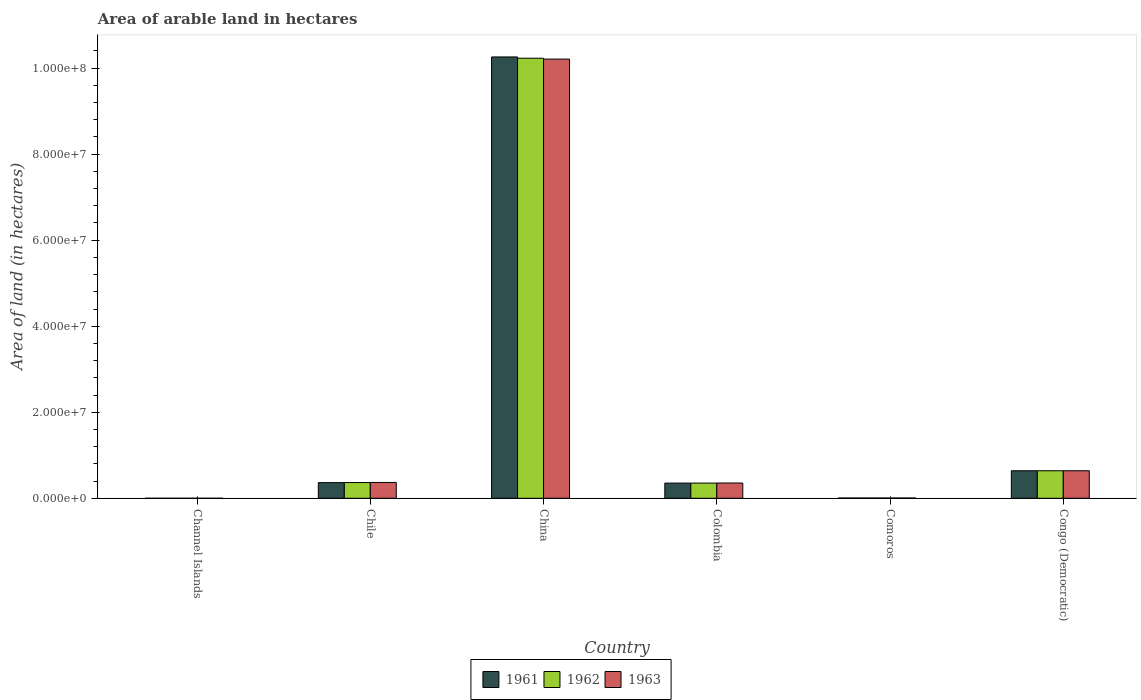How many bars are there on the 3rd tick from the left?
Offer a terse response. 3. What is the label of the 5th group of bars from the left?
Provide a succinct answer. Comoros. What is the total arable land in 1963 in Colombia?
Your answer should be very brief. 3.55e+06. Across all countries, what is the maximum total arable land in 1963?
Ensure brevity in your answer.  1.02e+08. Across all countries, what is the minimum total arable land in 1962?
Make the answer very short. 4000. In which country was the total arable land in 1962 minimum?
Provide a short and direct response. Channel Islands. What is the total total arable land in 1963 in the graph?
Offer a terse response. 1.16e+08. What is the difference between the total arable land in 1963 in Chile and that in China?
Give a very brief answer. -9.84e+07. What is the difference between the total arable land in 1961 in Colombia and the total arable land in 1962 in Channel Islands?
Ensure brevity in your answer.  3.53e+06. What is the average total arable land in 1963 per country?
Offer a terse response. 1.93e+07. What is the difference between the total arable land of/in 1962 and total arable land of/in 1963 in China?
Keep it short and to the point. 2.00e+05. In how many countries, is the total arable land in 1961 greater than 44000000 hectares?
Give a very brief answer. 1. What is the ratio of the total arable land in 1963 in China to that in Congo (Democratic)?
Provide a short and direct response. 15.95. Is the difference between the total arable land in 1962 in Chile and Colombia greater than the difference between the total arable land in 1963 in Chile and Colombia?
Offer a terse response. No. What is the difference between the highest and the second highest total arable land in 1962?
Make the answer very short. 9.59e+07. What is the difference between the highest and the lowest total arable land in 1962?
Offer a very short reply. 1.02e+08. In how many countries, is the total arable land in 1961 greater than the average total arable land in 1961 taken over all countries?
Give a very brief answer. 1. What does the 2nd bar from the left in Comoros represents?
Ensure brevity in your answer.  1962. What does the 1st bar from the right in Channel Islands represents?
Give a very brief answer. 1963. Is it the case that in every country, the sum of the total arable land in 1961 and total arable land in 1962 is greater than the total arable land in 1963?
Ensure brevity in your answer.  Yes. Are the values on the major ticks of Y-axis written in scientific E-notation?
Offer a very short reply. Yes. Does the graph contain grids?
Provide a succinct answer. No. What is the title of the graph?
Offer a very short reply. Area of arable land in hectares. What is the label or title of the Y-axis?
Give a very brief answer. Area of land (in hectares). What is the Area of land (in hectares) in 1961 in Channel Islands?
Make the answer very short. 4000. What is the Area of land (in hectares) in 1962 in Channel Islands?
Give a very brief answer. 4000. What is the Area of land (in hectares) in 1963 in Channel Islands?
Provide a succinct answer. 4000. What is the Area of land (in hectares) in 1961 in Chile?
Your answer should be compact. 3.64e+06. What is the Area of land (in hectares) in 1962 in Chile?
Provide a succinct answer. 3.66e+06. What is the Area of land (in hectares) of 1963 in Chile?
Your answer should be very brief. 3.68e+06. What is the Area of land (in hectares) of 1961 in China?
Ensure brevity in your answer.  1.03e+08. What is the Area of land (in hectares) of 1962 in China?
Make the answer very short. 1.02e+08. What is the Area of land (in hectares) of 1963 in China?
Provide a succinct answer. 1.02e+08. What is the Area of land (in hectares) in 1961 in Colombia?
Your answer should be very brief. 3.53e+06. What is the Area of land (in hectares) in 1962 in Colombia?
Give a very brief answer. 3.53e+06. What is the Area of land (in hectares) in 1963 in Colombia?
Your answer should be very brief. 3.55e+06. What is the Area of land (in hectares) in 1961 in Comoros?
Ensure brevity in your answer.  6.50e+04. What is the Area of land (in hectares) of 1962 in Comoros?
Keep it short and to the point. 6.50e+04. What is the Area of land (in hectares) of 1963 in Comoros?
Provide a succinct answer. 6.50e+04. What is the Area of land (in hectares) of 1961 in Congo (Democratic)?
Offer a terse response. 6.40e+06. What is the Area of land (in hectares) of 1962 in Congo (Democratic)?
Ensure brevity in your answer.  6.40e+06. What is the Area of land (in hectares) of 1963 in Congo (Democratic)?
Offer a very short reply. 6.40e+06. Across all countries, what is the maximum Area of land (in hectares) in 1961?
Provide a short and direct response. 1.03e+08. Across all countries, what is the maximum Area of land (in hectares) in 1962?
Your response must be concise. 1.02e+08. Across all countries, what is the maximum Area of land (in hectares) of 1963?
Your response must be concise. 1.02e+08. Across all countries, what is the minimum Area of land (in hectares) in 1961?
Ensure brevity in your answer.  4000. Across all countries, what is the minimum Area of land (in hectares) in 1962?
Ensure brevity in your answer.  4000. Across all countries, what is the minimum Area of land (in hectares) in 1963?
Provide a succinct answer. 4000. What is the total Area of land (in hectares) in 1961 in the graph?
Your response must be concise. 1.16e+08. What is the total Area of land (in hectares) of 1962 in the graph?
Give a very brief answer. 1.16e+08. What is the total Area of land (in hectares) in 1963 in the graph?
Offer a terse response. 1.16e+08. What is the difference between the Area of land (in hectares) in 1961 in Channel Islands and that in Chile?
Give a very brief answer. -3.64e+06. What is the difference between the Area of land (in hectares) of 1962 in Channel Islands and that in Chile?
Offer a very short reply. -3.66e+06. What is the difference between the Area of land (in hectares) of 1963 in Channel Islands and that in Chile?
Provide a succinct answer. -3.68e+06. What is the difference between the Area of land (in hectares) of 1961 in Channel Islands and that in China?
Keep it short and to the point. -1.03e+08. What is the difference between the Area of land (in hectares) in 1962 in Channel Islands and that in China?
Your answer should be very brief. -1.02e+08. What is the difference between the Area of land (in hectares) of 1963 in Channel Islands and that in China?
Provide a short and direct response. -1.02e+08. What is the difference between the Area of land (in hectares) of 1961 in Channel Islands and that in Colombia?
Give a very brief answer. -3.53e+06. What is the difference between the Area of land (in hectares) in 1962 in Channel Islands and that in Colombia?
Offer a very short reply. -3.53e+06. What is the difference between the Area of land (in hectares) in 1963 in Channel Islands and that in Colombia?
Your response must be concise. -3.55e+06. What is the difference between the Area of land (in hectares) of 1961 in Channel Islands and that in Comoros?
Provide a succinct answer. -6.10e+04. What is the difference between the Area of land (in hectares) of 1962 in Channel Islands and that in Comoros?
Your answer should be compact. -6.10e+04. What is the difference between the Area of land (in hectares) in 1963 in Channel Islands and that in Comoros?
Keep it short and to the point. -6.10e+04. What is the difference between the Area of land (in hectares) of 1961 in Channel Islands and that in Congo (Democratic)?
Your response must be concise. -6.40e+06. What is the difference between the Area of land (in hectares) of 1962 in Channel Islands and that in Congo (Democratic)?
Keep it short and to the point. -6.40e+06. What is the difference between the Area of land (in hectares) of 1963 in Channel Islands and that in Congo (Democratic)?
Your answer should be very brief. -6.40e+06. What is the difference between the Area of land (in hectares) in 1961 in Chile and that in China?
Your response must be concise. -9.90e+07. What is the difference between the Area of land (in hectares) of 1962 in Chile and that in China?
Your answer should be compact. -9.86e+07. What is the difference between the Area of land (in hectares) in 1963 in Chile and that in China?
Provide a succinct answer. -9.84e+07. What is the difference between the Area of land (in hectares) in 1961 in Chile and that in Colombia?
Your answer should be very brief. 1.08e+05. What is the difference between the Area of land (in hectares) in 1962 in Chile and that in Colombia?
Offer a terse response. 1.28e+05. What is the difference between the Area of land (in hectares) of 1963 in Chile and that in Colombia?
Your answer should be compact. 1.30e+05. What is the difference between the Area of land (in hectares) in 1961 in Chile and that in Comoros?
Your answer should be compact. 3.58e+06. What is the difference between the Area of land (in hectares) in 1962 in Chile and that in Comoros?
Offer a very short reply. 3.60e+06. What is the difference between the Area of land (in hectares) in 1963 in Chile and that in Comoros?
Offer a terse response. 3.62e+06. What is the difference between the Area of land (in hectares) in 1961 in Chile and that in Congo (Democratic)?
Give a very brief answer. -2.76e+06. What is the difference between the Area of land (in hectares) in 1962 in Chile and that in Congo (Democratic)?
Offer a terse response. -2.74e+06. What is the difference between the Area of land (in hectares) in 1963 in Chile and that in Congo (Democratic)?
Offer a terse response. -2.72e+06. What is the difference between the Area of land (in hectares) in 1961 in China and that in Colombia?
Offer a terse response. 9.91e+07. What is the difference between the Area of land (in hectares) in 1962 in China and that in Colombia?
Offer a very short reply. 9.88e+07. What is the difference between the Area of land (in hectares) of 1963 in China and that in Colombia?
Ensure brevity in your answer.  9.86e+07. What is the difference between the Area of land (in hectares) in 1961 in China and that in Comoros?
Your answer should be compact. 1.03e+08. What is the difference between the Area of land (in hectares) in 1962 in China and that in Comoros?
Make the answer very short. 1.02e+08. What is the difference between the Area of land (in hectares) in 1963 in China and that in Comoros?
Offer a terse response. 1.02e+08. What is the difference between the Area of land (in hectares) in 1961 in China and that in Congo (Democratic)?
Your answer should be very brief. 9.62e+07. What is the difference between the Area of land (in hectares) in 1962 in China and that in Congo (Democratic)?
Ensure brevity in your answer.  9.59e+07. What is the difference between the Area of land (in hectares) of 1963 in China and that in Congo (Democratic)?
Provide a succinct answer. 9.57e+07. What is the difference between the Area of land (in hectares) in 1961 in Colombia and that in Comoros?
Offer a terse response. 3.47e+06. What is the difference between the Area of land (in hectares) of 1962 in Colombia and that in Comoros?
Provide a succinct answer. 3.47e+06. What is the difference between the Area of land (in hectares) of 1963 in Colombia and that in Comoros?
Offer a terse response. 3.48e+06. What is the difference between the Area of land (in hectares) of 1961 in Colombia and that in Congo (Democratic)?
Your answer should be very brief. -2.87e+06. What is the difference between the Area of land (in hectares) of 1962 in Colombia and that in Congo (Democratic)?
Provide a short and direct response. -2.87e+06. What is the difference between the Area of land (in hectares) in 1963 in Colombia and that in Congo (Democratic)?
Provide a succinct answer. -2.85e+06. What is the difference between the Area of land (in hectares) of 1961 in Comoros and that in Congo (Democratic)?
Keep it short and to the point. -6.34e+06. What is the difference between the Area of land (in hectares) in 1962 in Comoros and that in Congo (Democratic)?
Make the answer very short. -6.34e+06. What is the difference between the Area of land (in hectares) in 1963 in Comoros and that in Congo (Democratic)?
Your answer should be compact. -6.34e+06. What is the difference between the Area of land (in hectares) in 1961 in Channel Islands and the Area of land (in hectares) in 1962 in Chile?
Provide a succinct answer. -3.66e+06. What is the difference between the Area of land (in hectares) in 1961 in Channel Islands and the Area of land (in hectares) in 1963 in Chile?
Make the answer very short. -3.68e+06. What is the difference between the Area of land (in hectares) of 1962 in Channel Islands and the Area of land (in hectares) of 1963 in Chile?
Provide a short and direct response. -3.68e+06. What is the difference between the Area of land (in hectares) in 1961 in Channel Islands and the Area of land (in hectares) in 1962 in China?
Give a very brief answer. -1.02e+08. What is the difference between the Area of land (in hectares) of 1961 in Channel Islands and the Area of land (in hectares) of 1963 in China?
Provide a short and direct response. -1.02e+08. What is the difference between the Area of land (in hectares) of 1962 in Channel Islands and the Area of land (in hectares) of 1963 in China?
Your response must be concise. -1.02e+08. What is the difference between the Area of land (in hectares) in 1961 in Channel Islands and the Area of land (in hectares) in 1962 in Colombia?
Ensure brevity in your answer.  -3.53e+06. What is the difference between the Area of land (in hectares) in 1961 in Channel Islands and the Area of land (in hectares) in 1963 in Colombia?
Give a very brief answer. -3.55e+06. What is the difference between the Area of land (in hectares) in 1962 in Channel Islands and the Area of land (in hectares) in 1963 in Colombia?
Give a very brief answer. -3.55e+06. What is the difference between the Area of land (in hectares) in 1961 in Channel Islands and the Area of land (in hectares) in 1962 in Comoros?
Offer a terse response. -6.10e+04. What is the difference between the Area of land (in hectares) of 1961 in Channel Islands and the Area of land (in hectares) of 1963 in Comoros?
Offer a very short reply. -6.10e+04. What is the difference between the Area of land (in hectares) in 1962 in Channel Islands and the Area of land (in hectares) in 1963 in Comoros?
Your answer should be very brief. -6.10e+04. What is the difference between the Area of land (in hectares) of 1961 in Channel Islands and the Area of land (in hectares) of 1962 in Congo (Democratic)?
Your answer should be very brief. -6.40e+06. What is the difference between the Area of land (in hectares) of 1961 in Channel Islands and the Area of land (in hectares) of 1963 in Congo (Democratic)?
Your answer should be very brief. -6.40e+06. What is the difference between the Area of land (in hectares) in 1962 in Channel Islands and the Area of land (in hectares) in 1963 in Congo (Democratic)?
Provide a succinct answer. -6.40e+06. What is the difference between the Area of land (in hectares) in 1961 in Chile and the Area of land (in hectares) in 1962 in China?
Your answer should be very brief. -9.87e+07. What is the difference between the Area of land (in hectares) of 1961 in Chile and the Area of land (in hectares) of 1963 in China?
Provide a succinct answer. -9.85e+07. What is the difference between the Area of land (in hectares) in 1962 in Chile and the Area of land (in hectares) in 1963 in China?
Ensure brevity in your answer.  -9.84e+07. What is the difference between the Area of land (in hectares) of 1961 in Chile and the Area of land (in hectares) of 1962 in Colombia?
Offer a terse response. 1.08e+05. What is the difference between the Area of land (in hectares) of 1961 in Chile and the Area of land (in hectares) of 1963 in Colombia?
Offer a very short reply. 9.00e+04. What is the difference between the Area of land (in hectares) of 1962 in Chile and the Area of land (in hectares) of 1963 in Colombia?
Your answer should be very brief. 1.10e+05. What is the difference between the Area of land (in hectares) in 1961 in Chile and the Area of land (in hectares) in 1962 in Comoros?
Your answer should be very brief. 3.58e+06. What is the difference between the Area of land (in hectares) in 1961 in Chile and the Area of land (in hectares) in 1963 in Comoros?
Make the answer very short. 3.58e+06. What is the difference between the Area of land (in hectares) in 1962 in Chile and the Area of land (in hectares) in 1963 in Comoros?
Offer a terse response. 3.60e+06. What is the difference between the Area of land (in hectares) in 1961 in Chile and the Area of land (in hectares) in 1962 in Congo (Democratic)?
Provide a short and direct response. -2.76e+06. What is the difference between the Area of land (in hectares) of 1961 in Chile and the Area of land (in hectares) of 1963 in Congo (Democratic)?
Offer a terse response. -2.76e+06. What is the difference between the Area of land (in hectares) of 1962 in Chile and the Area of land (in hectares) of 1963 in Congo (Democratic)?
Ensure brevity in your answer.  -2.74e+06. What is the difference between the Area of land (in hectares) in 1961 in China and the Area of land (in hectares) in 1962 in Colombia?
Provide a short and direct response. 9.91e+07. What is the difference between the Area of land (in hectares) in 1961 in China and the Area of land (in hectares) in 1963 in Colombia?
Make the answer very short. 9.90e+07. What is the difference between the Area of land (in hectares) of 1962 in China and the Area of land (in hectares) of 1963 in Colombia?
Provide a short and direct response. 9.88e+07. What is the difference between the Area of land (in hectares) in 1961 in China and the Area of land (in hectares) in 1962 in Comoros?
Keep it short and to the point. 1.03e+08. What is the difference between the Area of land (in hectares) of 1961 in China and the Area of land (in hectares) of 1963 in Comoros?
Provide a short and direct response. 1.03e+08. What is the difference between the Area of land (in hectares) in 1962 in China and the Area of land (in hectares) in 1963 in Comoros?
Provide a succinct answer. 1.02e+08. What is the difference between the Area of land (in hectares) in 1961 in China and the Area of land (in hectares) in 1962 in Congo (Democratic)?
Make the answer very short. 9.62e+07. What is the difference between the Area of land (in hectares) of 1961 in China and the Area of land (in hectares) of 1963 in Congo (Democratic)?
Your response must be concise. 9.62e+07. What is the difference between the Area of land (in hectares) in 1962 in China and the Area of land (in hectares) in 1963 in Congo (Democratic)?
Provide a short and direct response. 9.59e+07. What is the difference between the Area of land (in hectares) of 1961 in Colombia and the Area of land (in hectares) of 1962 in Comoros?
Provide a short and direct response. 3.47e+06. What is the difference between the Area of land (in hectares) in 1961 in Colombia and the Area of land (in hectares) in 1963 in Comoros?
Provide a succinct answer. 3.47e+06. What is the difference between the Area of land (in hectares) of 1962 in Colombia and the Area of land (in hectares) of 1963 in Comoros?
Give a very brief answer. 3.47e+06. What is the difference between the Area of land (in hectares) in 1961 in Colombia and the Area of land (in hectares) in 1962 in Congo (Democratic)?
Give a very brief answer. -2.87e+06. What is the difference between the Area of land (in hectares) in 1961 in Colombia and the Area of land (in hectares) in 1963 in Congo (Democratic)?
Ensure brevity in your answer.  -2.87e+06. What is the difference between the Area of land (in hectares) in 1962 in Colombia and the Area of land (in hectares) in 1963 in Congo (Democratic)?
Give a very brief answer. -2.87e+06. What is the difference between the Area of land (in hectares) in 1961 in Comoros and the Area of land (in hectares) in 1962 in Congo (Democratic)?
Your answer should be compact. -6.34e+06. What is the difference between the Area of land (in hectares) of 1961 in Comoros and the Area of land (in hectares) of 1963 in Congo (Democratic)?
Make the answer very short. -6.34e+06. What is the difference between the Area of land (in hectares) of 1962 in Comoros and the Area of land (in hectares) of 1963 in Congo (Democratic)?
Your response must be concise. -6.34e+06. What is the average Area of land (in hectares) of 1961 per country?
Give a very brief answer. 1.94e+07. What is the average Area of land (in hectares) in 1962 per country?
Your answer should be very brief. 1.93e+07. What is the average Area of land (in hectares) in 1963 per country?
Give a very brief answer. 1.93e+07. What is the difference between the Area of land (in hectares) in 1961 and Area of land (in hectares) in 1962 in Channel Islands?
Provide a short and direct response. 0. What is the difference between the Area of land (in hectares) in 1961 and Area of land (in hectares) in 1963 in Channel Islands?
Provide a succinct answer. 0. What is the difference between the Area of land (in hectares) of 1961 and Area of land (in hectares) of 1963 in Chile?
Give a very brief answer. -4.00e+04. What is the difference between the Area of land (in hectares) of 1961 and Area of land (in hectares) of 1963 in China?
Ensure brevity in your answer.  5.00e+05. What is the difference between the Area of land (in hectares) of 1961 and Area of land (in hectares) of 1962 in Colombia?
Offer a very short reply. 0. What is the difference between the Area of land (in hectares) of 1961 and Area of land (in hectares) of 1963 in Colombia?
Offer a very short reply. -1.80e+04. What is the difference between the Area of land (in hectares) in 1962 and Area of land (in hectares) in 1963 in Colombia?
Offer a very short reply. -1.80e+04. What is the difference between the Area of land (in hectares) in 1961 and Area of land (in hectares) in 1962 in Comoros?
Your answer should be very brief. 0. What is the difference between the Area of land (in hectares) in 1961 and Area of land (in hectares) in 1963 in Comoros?
Make the answer very short. 0. What is the ratio of the Area of land (in hectares) in 1961 in Channel Islands to that in Chile?
Provide a short and direct response. 0. What is the ratio of the Area of land (in hectares) in 1962 in Channel Islands to that in Chile?
Ensure brevity in your answer.  0. What is the ratio of the Area of land (in hectares) in 1963 in Channel Islands to that in Chile?
Give a very brief answer. 0. What is the ratio of the Area of land (in hectares) in 1963 in Channel Islands to that in China?
Your answer should be very brief. 0. What is the ratio of the Area of land (in hectares) of 1961 in Channel Islands to that in Colombia?
Offer a terse response. 0. What is the ratio of the Area of land (in hectares) of 1962 in Channel Islands to that in Colombia?
Offer a very short reply. 0. What is the ratio of the Area of land (in hectares) in 1963 in Channel Islands to that in Colombia?
Provide a short and direct response. 0. What is the ratio of the Area of land (in hectares) of 1961 in Channel Islands to that in Comoros?
Provide a succinct answer. 0.06. What is the ratio of the Area of land (in hectares) of 1962 in Channel Islands to that in Comoros?
Keep it short and to the point. 0.06. What is the ratio of the Area of land (in hectares) of 1963 in Channel Islands to that in Comoros?
Offer a terse response. 0.06. What is the ratio of the Area of land (in hectares) in 1961 in Channel Islands to that in Congo (Democratic)?
Keep it short and to the point. 0. What is the ratio of the Area of land (in hectares) in 1962 in Channel Islands to that in Congo (Democratic)?
Make the answer very short. 0. What is the ratio of the Area of land (in hectares) of 1963 in Channel Islands to that in Congo (Democratic)?
Keep it short and to the point. 0. What is the ratio of the Area of land (in hectares) in 1961 in Chile to that in China?
Offer a very short reply. 0.04. What is the ratio of the Area of land (in hectares) of 1962 in Chile to that in China?
Make the answer very short. 0.04. What is the ratio of the Area of land (in hectares) in 1963 in Chile to that in China?
Your answer should be compact. 0.04. What is the ratio of the Area of land (in hectares) of 1961 in Chile to that in Colombia?
Offer a very short reply. 1.03. What is the ratio of the Area of land (in hectares) in 1962 in Chile to that in Colombia?
Your answer should be compact. 1.04. What is the ratio of the Area of land (in hectares) of 1963 in Chile to that in Colombia?
Your answer should be compact. 1.04. What is the ratio of the Area of land (in hectares) of 1962 in Chile to that in Comoros?
Your answer should be very brief. 56.31. What is the ratio of the Area of land (in hectares) in 1963 in Chile to that in Comoros?
Give a very brief answer. 56.62. What is the ratio of the Area of land (in hectares) in 1961 in Chile to that in Congo (Democratic)?
Keep it short and to the point. 0.57. What is the ratio of the Area of land (in hectares) in 1962 in Chile to that in Congo (Democratic)?
Offer a terse response. 0.57. What is the ratio of the Area of land (in hectares) in 1963 in Chile to that in Congo (Democratic)?
Your answer should be compact. 0.57. What is the ratio of the Area of land (in hectares) of 1961 in China to that in Colombia?
Give a very brief answer. 29.05. What is the ratio of the Area of land (in hectares) of 1962 in China to that in Colombia?
Your answer should be very brief. 28.96. What is the ratio of the Area of land (in hectares) in 1963 in China to that in Colombia?
Offer a very short reply. 28.76. What is the ratio of the Area of land (in hectares) of 1961 in China to that in Comoros?
Provide a short and direct response. 1578.46. What is the ratio of the Area of land (in hectares) of 1962 in China to that in Comoros?
Your answer should be very brief. 1573.85. What is the ratio of the Area of land (in hectares) in 1963 in China to that in Comoros?
Your answer should be very brief. 1570.77. What is the ratio of the Area of land (in hectares) of 1961 in China to that in Congo (Democratic)?
Your answer should be very brief. 16.03. What is the ratio of the Area of land (in hectares) of 1962 in China to that in Congo (Democratic)?
Provide a short and direct response. 15.98. What is the ratio of the Area of land (in hectares) of 1963 in China to that in Congo (Democratic)?
Your response must be concise. 15.95. What is the ratio of the Area of land (in hectares) in 1961 in Colombia to that in Comoros?
Offer a very short reply. 54.34. What is the ratio of the Area of land (in hectares) of 1962 in Colombia to that in Comoros?
Your answer should be compact. 54.34. What is the ratio of the Area of land (in hectares) in 1963 in Colombia to that in Comoros?
Your answer should be compact. 54.62. What is the ratio of the Area of land (in hectares) in 1961 in Colombia to that in Congo (Democratic)?
Offer a terse response. 0.55. What is the ratio of the Area of land (in hectares) of 1962 in Colombia to that in Congo (Democratic)?
Give a very brief answer. 0.55. What is the ratio of the Area of land (in hectares) in 1963 in Colombia to that in Congo (Democratic)?
Your answer should be very brief. 0.55. What is the ratio of the Area of land (in hectares) of 1961 in Comoros to that in Congo (Democratic)?
Offer a very short reply. 0.01. What is the ratio of the Area of land (in hectares) in 1962 in Comoros to that in Congo (Democratic)?
Ensure brevity in your answer.  0.01. What is the ratio of the Area of land (in hectares) in 1963 in Comoros to that in Congo (Democratic)?
Give a very brief answer. 0.01. What is the difference between the highest and the second highest Area of land (in hectares) in 1961?
Ensure brevity in your answer.  9.62e+07. What is the difference between the highest and the second highest Area of land (in hectares) of 1962?
Provide a succinct answer. 9.59e+07. What is the difference between the highest and the second highest Area of land (in hectares) in 1963?
Provide a short and direct response. 9.57e+07. What is the difference between the highest and the lowest Area of land (in hectares) in 1961?
Your answer should be compact. 1.03e+08. What is the difference between the highest and the lowest Area of land (in hectares) in 1962?
Offer a very short reply. 1.02e+08. What is the difference between the highest and the lowest Area of land (in hectares) of 1963?
Provide a succinct answer. 1.02e+08. 